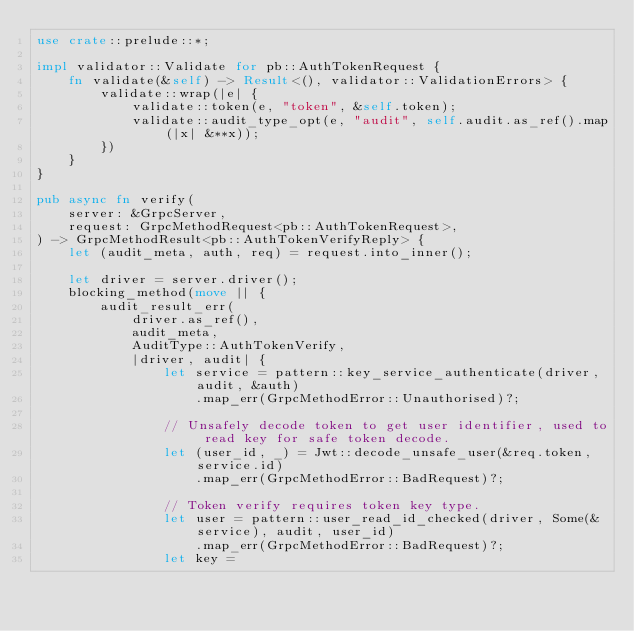<code> <loc_0><loc_0><loc_500><loc_500><_Rust_>use crate::prelude::*;

impl validator::Validate for pb::AuthTokenRequest {
    fn validate(&self) -> Result<(), validator::ValidationErrors> {
        validate::wrap(|e| {
            validate::token(e, "token", &self.token);
            validate::audit_type_opt(e, "audit", self.audit.as_ref().map(|x| &**x));
        })
    }
}

pub async fn verify(
    server: &GrpcServer,
    request: GrpcMethodRequest<pb::AuthTokenRequest>,
) -> GrpcMethodResult<pb::AuthTokenVerifyReply> {
    let (audit_meta, auth, req) = request.into_inner();

    let driver = server.driver();
    blocking_method(move || {
        audit_result_err(
            driver.as_ref(),
            audit_meta,
            AuditType::AuthTokenVerify,
            |driver, audit| {
                let service = pattern::key_service_authenticate(driver, audit, &auth)
                    .map_err(GrpcMethodError::Unauthorised)?;

                // Unsafely decode token to get user identifier, used to read key for safe token decode.
                let (user_id, _) = Jwt::decode_unsafe_user(&req.token, service.id)
                    .map_err(GrpcMethodError::BadRequest)?;

                // Token verify requires token key type.
                let user = pattern::user_read_id_checked(driver, Some(&service), audit, user_id)
                    .map_err(GrpcMethodError::BadRequest)?;
                let key =</code> 